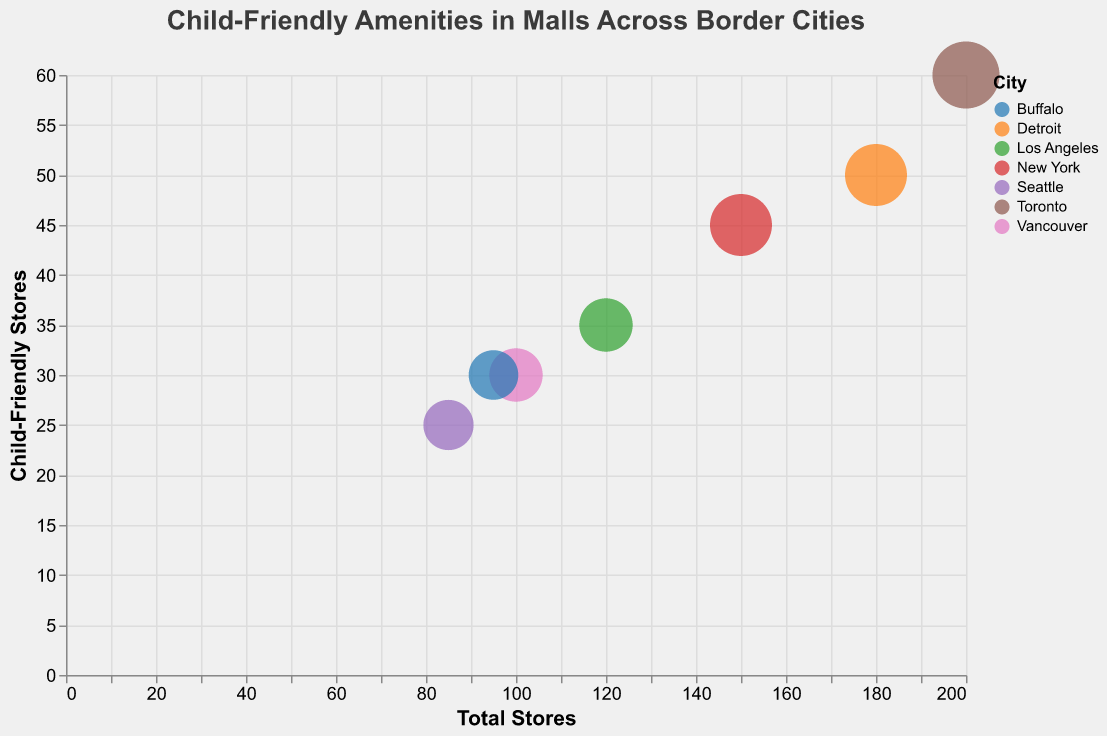What is the title of the figure? The title of the figure is displayed at the top and is meant to provide a summary of what the chart represents.
Answer: Child-Friendly Amenities in Malls Across Border Cities How many cities are represented in the chart? To find the number of cities, look at the different colors in the legend representing various cities.
Answer: 7 Which mall has the highest number of child-friendly stores? Looking at the y-axis (Child-Friendly Stores) and finding the highest point will tell us which mall has the highest number of child-friendly stores.
Answer: Eaton Centre What is the size of the bubble for Queens Center in New York? Finding New York in the tooltip or legend and checking the bubble size will give the answer.
Answer: 55 Which city has the mall with the smallest number of total stores? Looking along the x-axis for the smallest value of Total Stores and checking the corresponding city will provide the answer.
Answer: Westlake Center (Seattle) How many Recreation Facilities are there in Somerset Collection in Detroit? By using the tooltip to find Detroit's Somerset Collection and reading the value under Recreation Facilities, we can get the answer.
Answer: 9 What is the total number of child-friendly stores in Pacific Centre and Westlake Center combined? Add the number of child-friendly stores for Pacific Centre (30) and Westlake Center (25). 30 + 25 = 55
Answer: 55 Which mall has more child-friendly stores, The Beverly Center in Los Angeles or Williamsville Place in Buffalo? Compare the y-axis values for The Beverly Center and Williamsville Place. The Beverly Center has 35 and Williamsville Place has 30.
Answer: The Beverly Center Is there a city where the size of the bubble is equal for two different malls? Check the size of the bubbles across all cities to verify if any two have equal sizes. In the provided data, no two malls have the same BubbleSize.
Answer: No What percentage of stores in Eaton Centre are child-friendly? Divide the number of Child-Friendly Stores (60) by Total Stores (200) and multiply by 100. (60/200) * 100 = 30%
Answer: 30% 